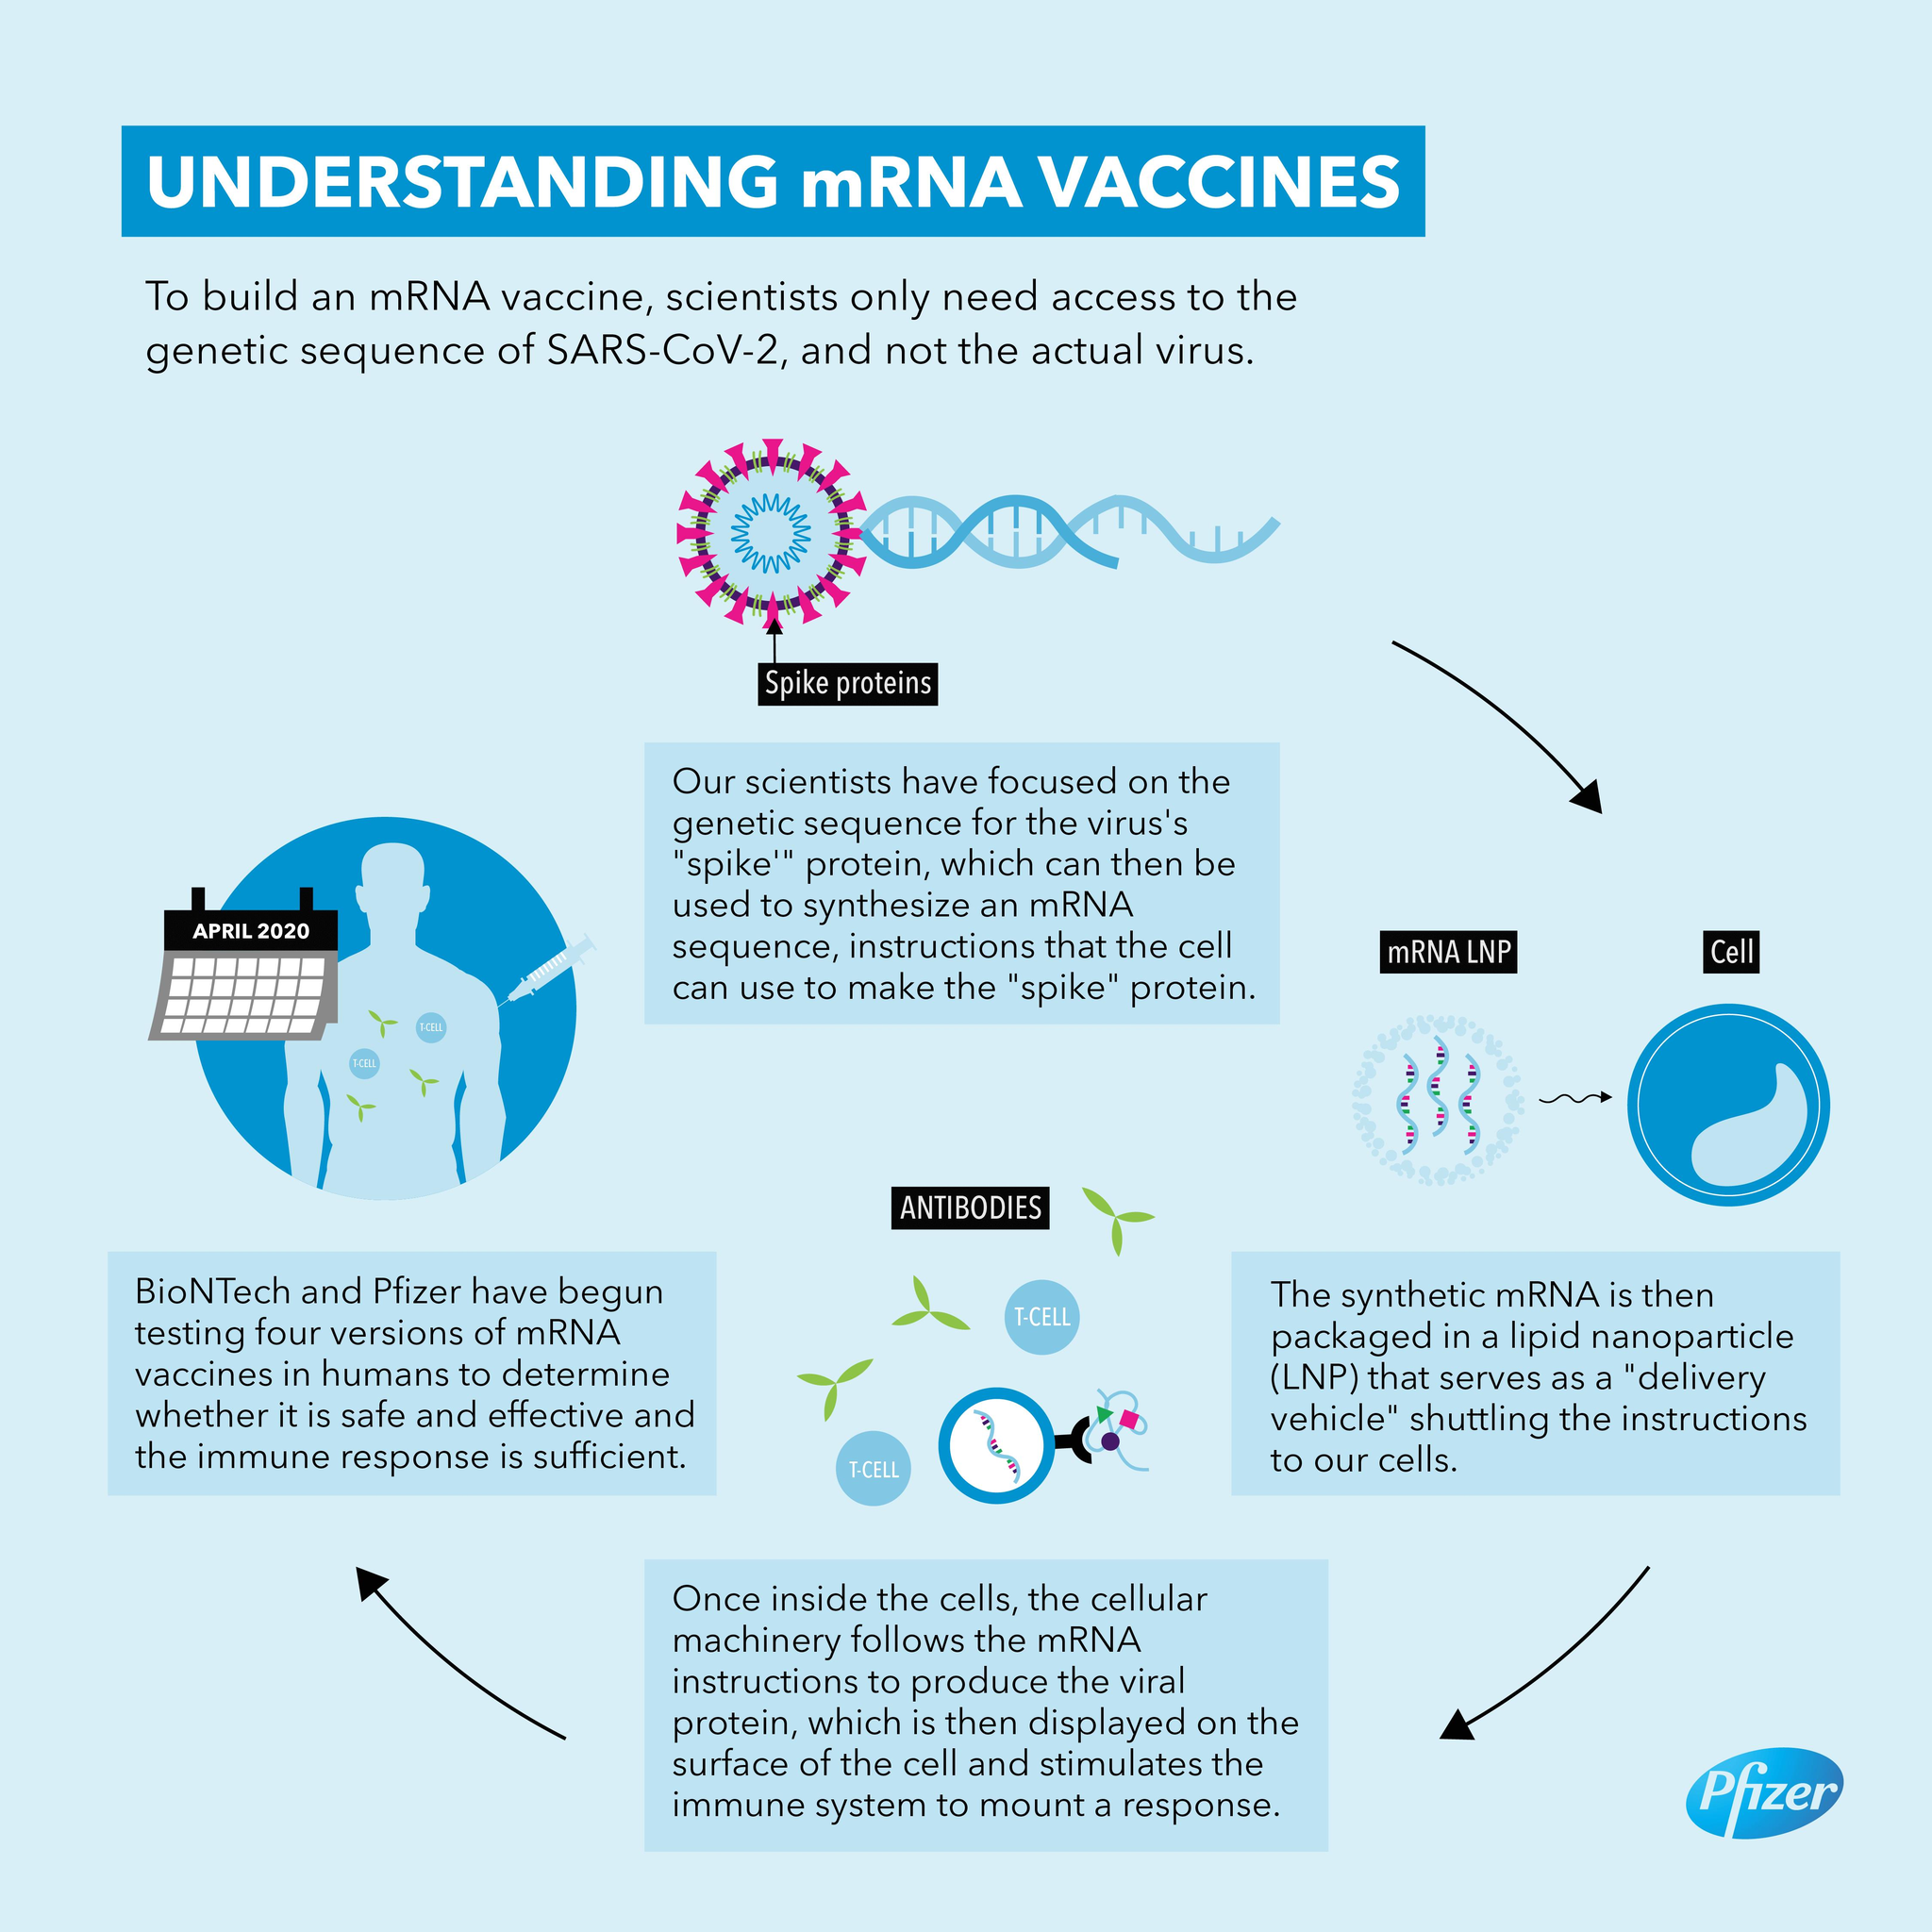Highlight a few significant elements in this photo. There are only 2 T-CELLs depicted in this infographic. 